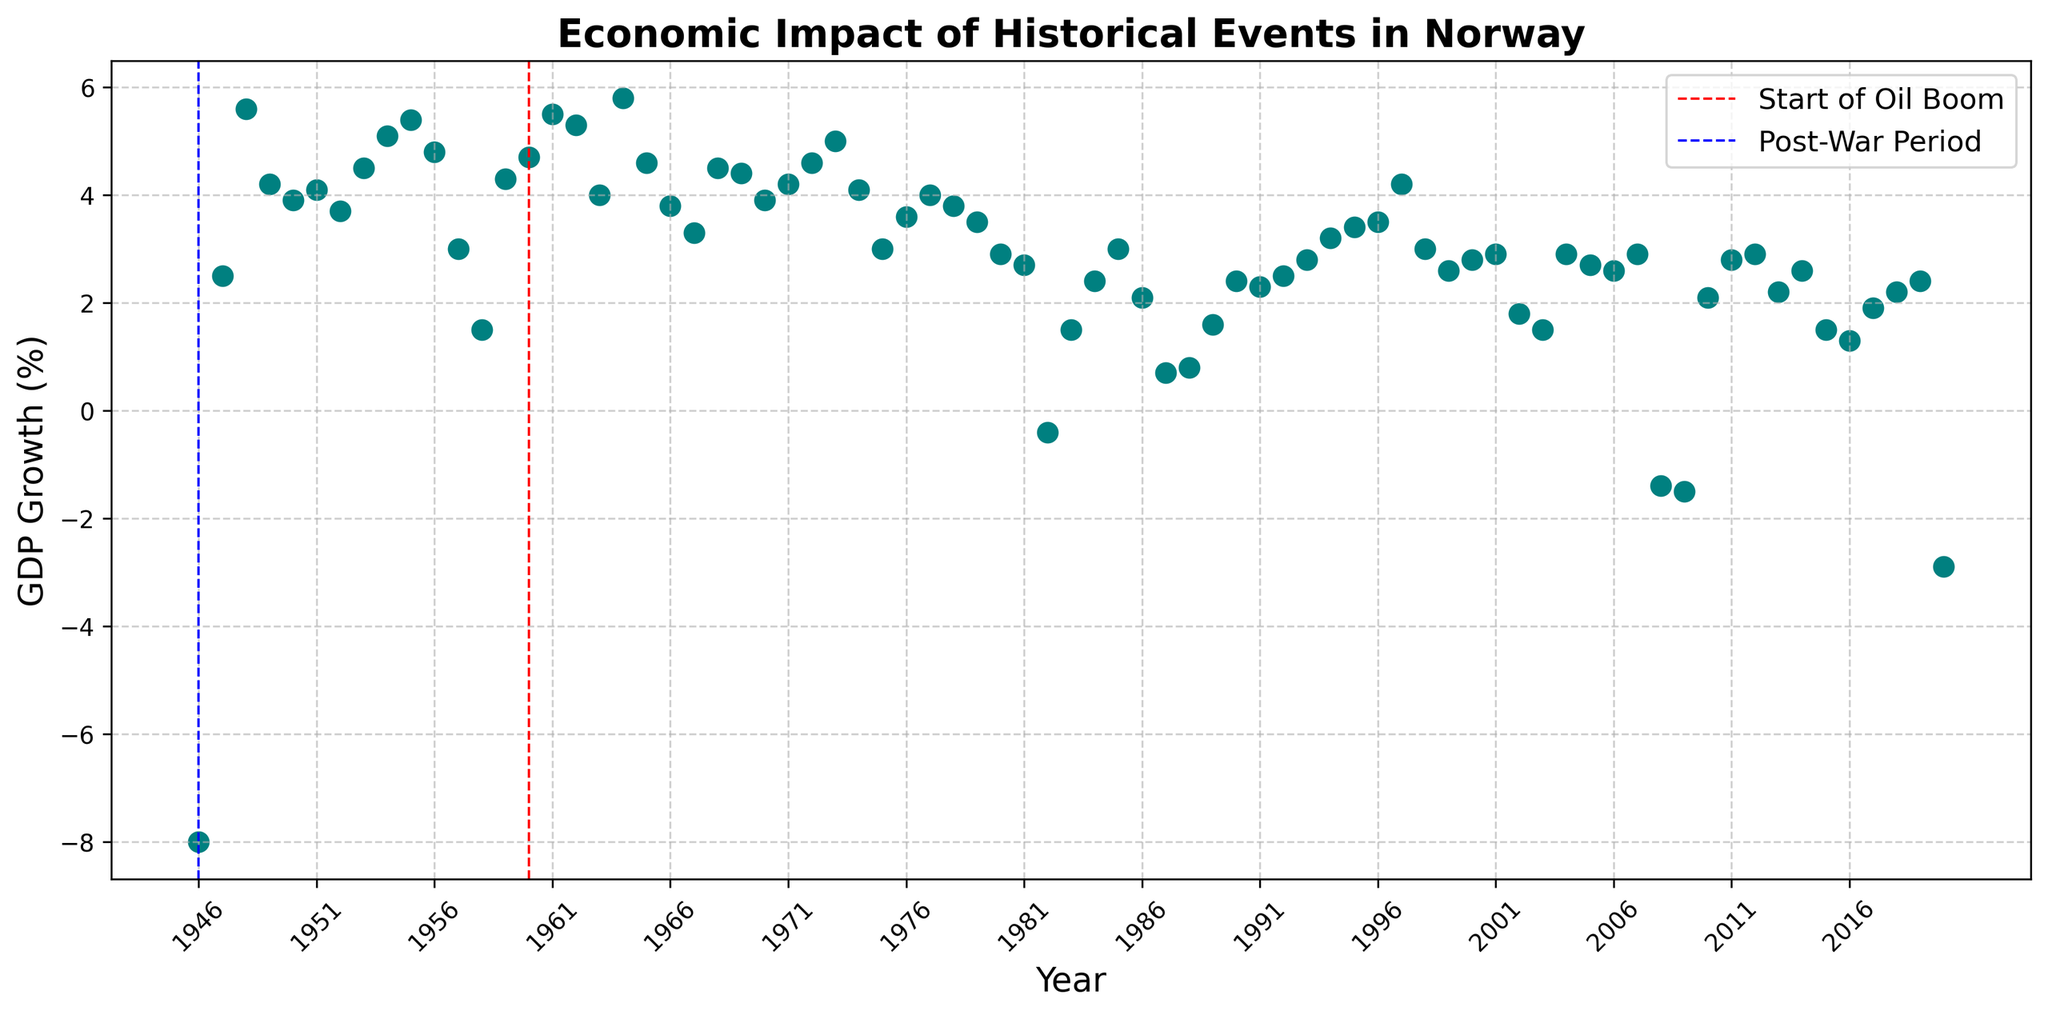What is the GDP growth rate for the year 1946? To find the GDP growth rate for 1946, locate the data point on the scatter plot corresponding to the year 1946. The value for GDP growth is directly labeled on the y-axis.
Answer: -8.0% What are the years with negative GDP growth rates, and what are their values? Check the scatter plot for data points below the x-axis (0% GDP growth). Identify these years and note their corresponding values on the y-axis.
Answer: 1946: -8.0%, 1982: -0.4%, 2008: -1.4%, 2009: -1.5%, 2020: -2.9% Which year experienced the highest GDP growth rate, and what was the rate? Look for the highest point above the x-axis on the scatter plot and note the year and the GDP growth value.
Answer: 1964, 5.8% How does the GDP growth rate in 1980 compare to that in 1981? Identify the GDP growth rates for 1980 and 1981 on the scatter plot and compare their values to determine which is higher.
Answer: 1980 > 1981 Calculate the average GDP growth rate during the post-war period (1946-1960). Identify the GDP growth rates from 1946 to 1960. Sum these values and then divide by the number of years in this range.
Answer: Average = ( -8.0 + 2.5 + 5.6 + 4.2 + 3.9 + 4.1 + 3.7 + 4.5 + 5.1 + 5.4 + 4.8 + 3.0 + 1.5 + 4.3 + 4.7 ) / 15 = 3.28% What impact did the oil boom starting in 1960 have on GDP growth rate trends in the following decade? Compare GDP growth rates before and after 1960 by examining the scatter plot and noting general trends in the decade following 1960.
Answer: Positive impact; higher GDP growth rates on average in the 1960s Identify the period with the most volatile GDP growth, and describe the pattern. Look for periods with the largest fluctuations between positive and negative GDP growth rates on the scatter plot and describe the changes.
Answer: Early 1980s, fluctuating between positive and negative values What is the cumulative GDP growth from 2000 to 2010? Sum the GDP growth rates for each year from 2000 to 2010.
Answer: Cumulative = 2.8 + 2.9 + 1.8 + 1.5 + 2.9 + 2.7 + 2.6 + 2.9 - 1.4 - 1.5 + 2.1 = 18.3% How did the GDP growth rate change from the post-war period to the oil boom period? Compare the average GDP growth rates from 1946-1960 (post-war) to 1961-1970 (beginning of oil boom).
Answer: From 3.28% to approximately 4.48% (1955-1970 average calculated similarly) Which historical event had the most significant negative impact on GDP growth, based on the scatter plot? Locate the largest negative data points on the scatter plot and refer to the contextual information provided by the vertical lines marking historical events.
Answer: COVID-19 pandemic in 2020 